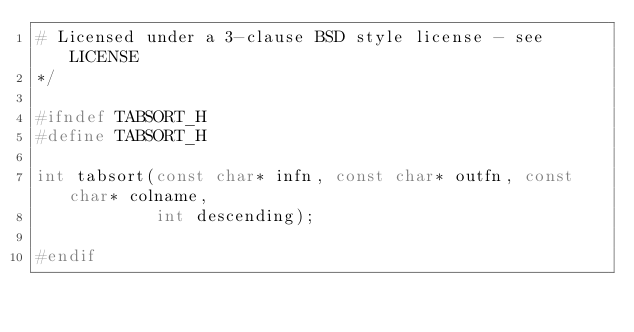Convert code to text. <code><loc_0><loc_0><loc_500><loc_500><_C_># Licensed under a 3-clause BSD style license - see LICENSE
*/

#ifndef TABSORT_H
#define TABSORT_H

int tabsort(const char* infn, const char* outfn, const char* colname,
            int descending);

#endif
</code> 